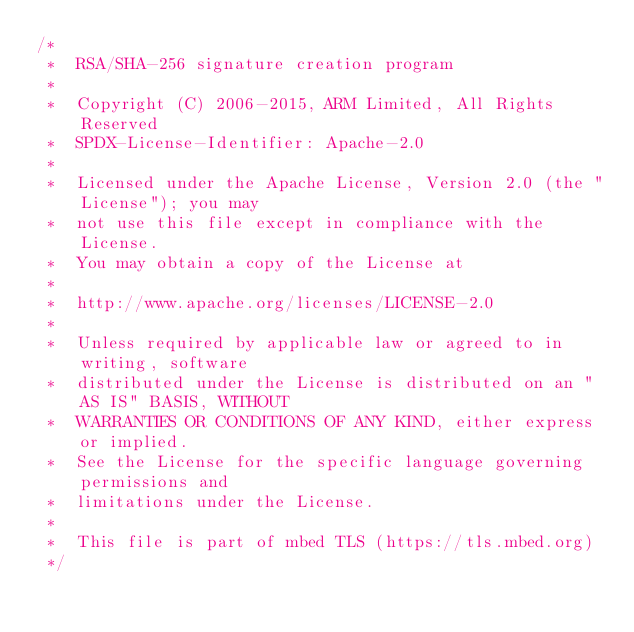Convert code to text. <code><loc_0><loc_0><loc_500><loc_500><_C_>/*
 *  RSA/SHA-256 signature creation program
 *
 *  Copyright (C) 2006-2015, ARM Limited, All Rights Reserved
 *  SPDX-License-Identifier: Apache-2.0
 *
 *  Licensed under the Apache License, Version 2.0 (the "License"); you may
 *  not use this file except in compliance with the License.
 *  You may obtain a copy of the License at
 *
 *  http://www.apache.org/licenses/LICENSE-2.0
 *
 *  Unless required by applicable law or agreed to in writing, software
 *  distributed under the License is distributed on an "AS IS" BASIS, WITHOUT
 *  WARRANTIES OR CONDITIONS OF ANY KIND, either express or implied.
 *  See the License for the specific language governing permissions and
 *  limitations under the License.
 *
 *  This file is part of mbed TLS (https://tls.mbed.org)
 */
</code> 